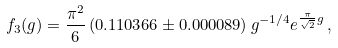<formula> <loc_0><loc_0><loc_500><loc_500>f _ { 3 } ( g ) = \frac { \pi ^ { 2 } } { 6 } \, ( 0 . 1 1 0 3 6 6 \pm 0 . 0 0 0 0 8 9 ) \, g ^ { - 1 / 4 } e ^ { \frac { \pi } { \sqrt { 2 } } g } \, ,</formula> 